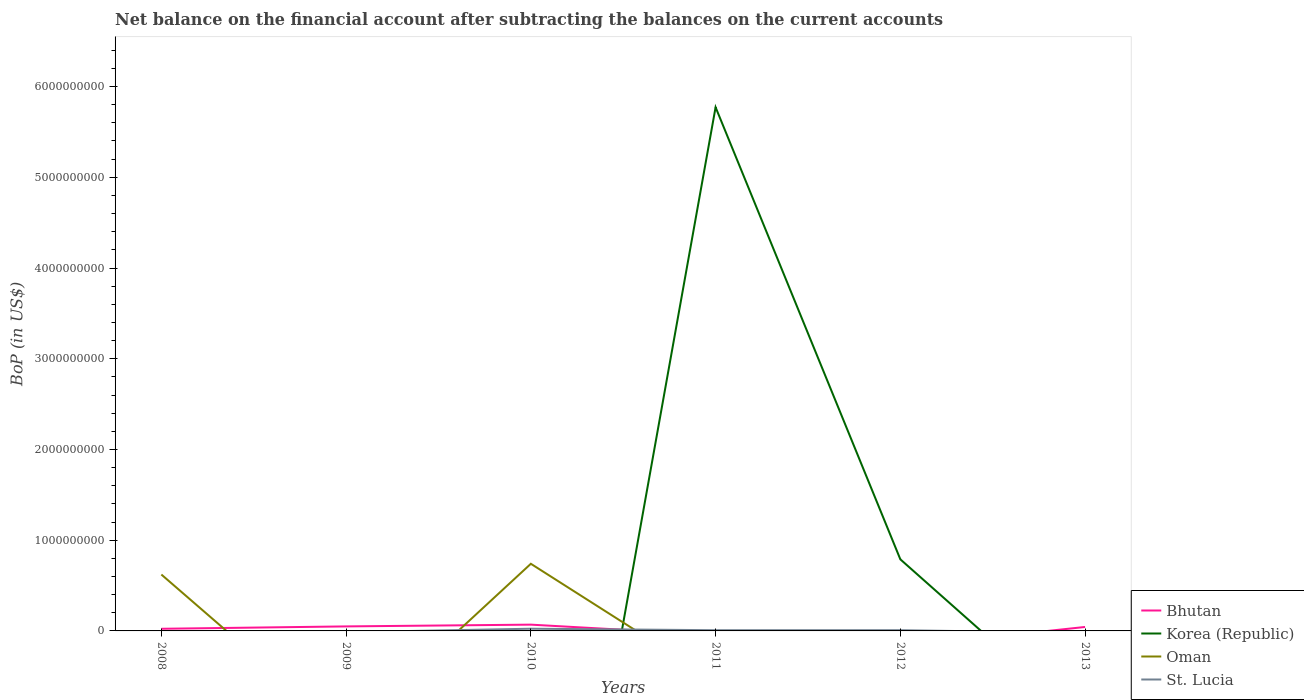Across all years, what is the maximum Balance of Payments in Oman?
Your response must be concise. 0. What is the total Balance of Payments in Bhutan in the graph?
Provide a succinct answer. 2.56e+07. What is the difference between the highest and the second highest Balance of Payments in Oman?
Your answer should be very brief. 7.40e+08. What is the difference between the highest and the lowest Balance of Payments in St. Lucia?
Ensure brevity in your answer.  3. How many lines are there?
Offer a terse response. 4. Are the values on the major ticks of Y-axis written in scientific E-notation?
Ensure brevity in your answer.  No. What is the title of the graph?
Provide a short and direct response. Net balance on the financial account after subtracting the balances on the current accounts. What is the label or title of the Y-axis?
Your answer should be compact. BoP (in US$). What is the BoP (in US$) in Bhutan in 2008?
Your answer should be very brief. 2.36e+07. What is the BoP (in US$) of Oman in 2008?
Make the answer very short. 6.22e+08. What is the BoP (in US$) in Bhutan in 2009?
Give a very brief answer. 4.98e+07. What is the BoP (in US$) in St. Lucia in 2009?
Offer a very short reply. 0. What is the BoP (in US$) of Bhutan in 2010?
Provide a short and direct response. 6.92e+07. What is the BoP (in US$) of Oman in 2010?
Your answer should be compact. 7.40e+08. What is the BoP (in US$) of St. Lucia in 2010?
Offer a very short reply. 2.43e+07. What is the BoP (in US$) of Korea (Republic) in 2011?
Ensure brevity in your answer.  5.77e+09. What is the BoP (in US$) in Oman in 2011?
Provide a succinct answer. 0. What is the BoP (in US$) in St. Lucia in 2011?
Give a very brief answer. 7.85e+06. What is the BoP (in US$) of Korea (Republic) in 2012?
Your answer should be compact. 7.89e+08. What is the BoP (in US$) in St. Lucia in 2012?
Provide a short and direct response. 8.10e+06. What is the BoP (in US$) in Bhutan in 2013?
Offer a very short reply. 4.36e+07. Across all years, what is the maximum BoP (in US$) of Bhutan?
Give a very brief answer. 6.92e+07. Across all years, what is the maximum BoP (in US$) of Korea (Republic)?
Offer a terse response. 5.77e+09. Across all years, what is the maximum BoP (in US$) in Oman?
Provide a short and direct response. 7.40e+08. Across all years, what is the maximum BoP (in US$) of St. Lucia?
Your response must be concise. 2.43e+07. Across all years, what is the minimum BoP (in US$) in St. Lucia?
Provide a short and direct response. 0. What is the total BoP (in US$) of Bhutan in the graph?
Provide a short and direct response. 1.86e+08. What is the total BoP (in US$) of Korea (Republic) in the graph?
Give a very brief answer. 6.56e+09. What is the total BoP (in US$) of Oman in the graph?
Your answer should be very brief. 1.36e+09. What is the total BoP (in US$) in St. Lucia in the graph?
Ensure brevity in your answer.  4.03e+07. What is the difference between the BoP (in US$) of Bhutan in 2008 and that in 2009?
Your answer should be very brief. -2.62e+07. What is the difference between the BoP (in US$) in Bhutan in 2008 and that in 2010?
Provide a succinct answer. -4.56e+07. What is the difference between the BoP (in US$) of Oman in 2008 and that in 2010?
Make the answer very short. -1.18e+08. What is the difference between the BoP (in US$) of Bhutan in 2008 and that in 2013?
Offer a terse response. -2.00e+07. What is the difference between the BoP (in US$) of Bhutan in 2009 and that in 2010?
Keep it short and to the point. -1.94e+07. What is the difference between the BoP (in US$) in Bhutan in 2009 and that in 2013?
Offer a terse response. 6.19e+06. What is the difference between the BoP (in US$) in St. Lucia in 2010 and that in 2011?
Your answer should be very brief. 1.64e+07. What is the difference between the BoP (in US$) in St. Lucia in 2010 and that in 2012?
Give a very brief answer. 1.62e+07. What is the difference between the BoP (in US$) of Bhutan in 2010 and that in 2013?
Your response must be concise. 2.56e+07. What is the difference between the BoP (in US$) of Korea (Republic) in 2011 and that in 2012?
Give a very brief answer. 4.98e+09. What is the difference between the BoP (in US$) in St. Lucia in 2011 and that in 2012?
Make the answer very short. -2.51e+05. What is the difference between the BoP (in US$) of Bhutan in 2008 and the BoP (in US$) of Oman in 2010?
Offer a terse response. -7.17e+08. What is the difference between the BoP (in US$) of Bhutan in 2008 and the BoP (in US$) of St. Lucia in 2010?
Your answer should be compact. -7.40e+05. What is the difference between the BoP (in US$) in Oman in 2008 and the BoP (in US$) in St. Lucia in 2010?
Ensure brevity in your answer.  5.97e+08. What is the difference between the BoP (in US$) of Bhutan in 2008 and the BoP (in US$) of Korea (Republic) in 2011?
Provide a succinct answer. -5.75e+09. What is the difference between the BoP (in US$) of Bhutan in 2008 and the BoP (in US$) of St. Lucia in 2011?
Your answer should be very brief. 1.57e+07. What is the difference between the BoP (in US$) in Oman in 2008 and the BoP (in US$) in St. Lucia in 2011?
Keep it short and to the point. 6.14e+08. What is the difference between the BoP (in US$) in Bhutan in 2008 and the BoP (in US$) in Korea (Republic) in 2012?
Your response must be concise. -7.66e+08. What is the difference between the BoP (in US$) of Bhutan in 2008 and the BoP (in US$) of St. Lucia in 2012?
Your response must be concise. 1.55e+07. What is the difference between the BoP (in US$) of Oman in 2008 and the BoP (in US$) of St. Lucia in 2012?
Your response must be concise. 6.14e+08. What is the difference between the BoP (in US$) of Bhutan in 2009 and the BoP (in US$) of Oman in 2010?
Offer a very short reply. -6.90e+08. What is the difference between the BoP (in US$) in Bhutan in 2009 and the BoP (in US$) in St. Lucia in 2010?
Offer a very short reply. 2.55e+07. What is the difference between the BoP (in US$) in Bhutan in 2009 and the BoP (in US$) in Korea (Republic) in 2011?
Make the answer very short. -5.72e+09. What is the difference between the BoP (in US$) of Bhutan in 2009 and the BoP (in US$) of St. Lucia in 2011?
Your answer should be very brief. 4.19e+07. What is the difference between the BoP (in US$) in Bhutan in 2009 and the BoP (in US$) in Korea (Republic) in 2012?
Provide a succinct answer. -7.39e+08. What is the difference between the BoP (in US$) of Bhutan in 2009 and the BoP (in US$) of St. Lucia in 2012?
Give a very brief answer. 4.17e+07. What is the difference between the BoP (in US$) of Bhutan in 2010 and the BoP (in US$) of Korea (Republic) in 2011?
Ensure brevity in your answer.  -5.70e+09. What is the difference between the BoP (in US$) of Bhutan in 2010 and the BoP (in US$) of St. Lucia in 2011?
Ensure brevity in your answer.  6.13e+07. What is the difference between the BoP (in US$) in Oman in 2010 and the BoP (in US$) in St. Lucia in 2011?
Ensure brevity in your answer.  7.32e+08. What is the difference between the BoP (in US$) in Bhutan in 2010 and the BoP (in US$) in Korea (Republic) in 2012?
Provide a succinct answer. -7.20e+08. What is the difference between the BoP (in US$) in Bhutan in 2010 and the BoP (in US$) in St. Lucia in 2012?
Provide a short and direct response. 6.11e+07. What is the difference between the BoP (in US$) in Oman in 2010 and the BoP (in US$) in St. Lucia in 2012?
Offer a terse response. 7.32e+08. What is the difference between the BoP (in US$) of Korea (Republic) in 2011 and the BoP (in US$) of St. Lucia in 2012?
Offer a terse response. 5.76e+09. What is the average BoP (in US$) in Bhutan per year?
Give a very brief answer. 3.10e+07. What is the average BoP (in US$) in Korea (Republic) per year?
Offer a terse response. 1.09e+09. What is the average BoP (in US$) of Oman per year?
Offer a terse response. 2.27e+08. What is the average BoP (in US$) of St. Lucia per year?
Give a very brief answer. 6.71e+06. In the year 2008, what is the difference between the BoP (in US$) in Bhutan and BoP (in US$) in Oman?
Your response must be concise. -5.98e+08. In the year 2010, what is the difference between the BoP (in US$) in Bhutan and BoP (in US$) in Oman?
Offer a very short reply. -6.71e+08. In the year 2010, what is the difference between the BoP (in US$) in Bhutan and BoP (in US$) in St. Lucia?
Offer a very short reply. 4.49e+07. In the year 2010, what is the difference between the BoP (in US$) in Oman and BoP (in US$) in St. Lucia?
Keep it short and to the point. 7.16e+08. In the year 2011, what is the difference between the BoP (in US$) in Korea (Republic) and BoP (in US$) in St. Lucia?
Provide a succinct answer. 5.76e+09. In the year 2012, what is the difference between the BoP (in US$) in Korea (Republic) and BoP (in US$) in St. Lucia?
Offer a very short reply. 7.81e+08. What is the ratio of the BoP (in US$) of Bhutan in 2008 to that in 2009?
Make the answer very short. 0.47. What is the ratio of the BoP (in US$) of Bhutan in 2008 to that in 2010?
Offer a terse response. 0.34. What is the ratio of the BoP (in US$) in Oman in 2008 to that in 2010?
Give a very brief answer. 0.84. What is the ratio of the BoP (in US$) of Bhutan in 2008 to that in 2013?
Your answer should be very brief. 0.54. What is the ratio of the BoP (in US$) of Bhutan in 2009 to that in 2010?
Your answer should be compact. 0.72. What is the ratio of the BoP (in US$) of Bhutan in 2009 to that in 2013?
Your response must be concise. 1.14. What is the ratio of the BoP (in US$) in St. Lucia in 2010 to that in 2011?
Offer a terse response. 3.09. What is the ratio of the BoP (in US$) in St. Lucia in 2010 to that in 2012?
Offer a terse response. 3. What is the ratio of the BoP (in US$) of Bhutan in 2010 to that in 2013?
Provide a succinct answer. 1.59. What is the ratio of the BoP (in US$) in Korea (Republic) in 2011 to that in 2012?
Provide a short and direct response. 7.31. What is the ratio of the BoP (in US$) in St. Lucia in 2011 to that in 2012?
Keep it short and to the point. 0.97. What is the difference between the highest and the second highest BoP (in US$) of Bhutan?
Ensure brevity in your answer.  1.94e+07. What is the difference between the highest and the second highest BoP (in US$) in St. Lucia?
Provide a succinct answer. 1.62e+07. What is the difference between the highest and the lowest BoP (in US$) in Bhutan?
Offer a very short reply. 6.92e+07. What is the difference between the highest and the lowest BoP (in US$) of Korea (Republic)?
Your answer should be compact. 5.77e+09. What is the difference between the highest and the lowest BoP (in US$) in Oman?
Your answer should be compact. 7.40e+08. What is the difference between the highest and the lowest BoP (in US$) in St. Lucia?
Your answer should be compact. 2.43e+07. 